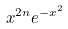Convert formula to latex. <formula><loc_0><loc_0><loc_500><loc_500>x ^ { 2 n } e ^ { - x ^ { 2 } }</formula> 